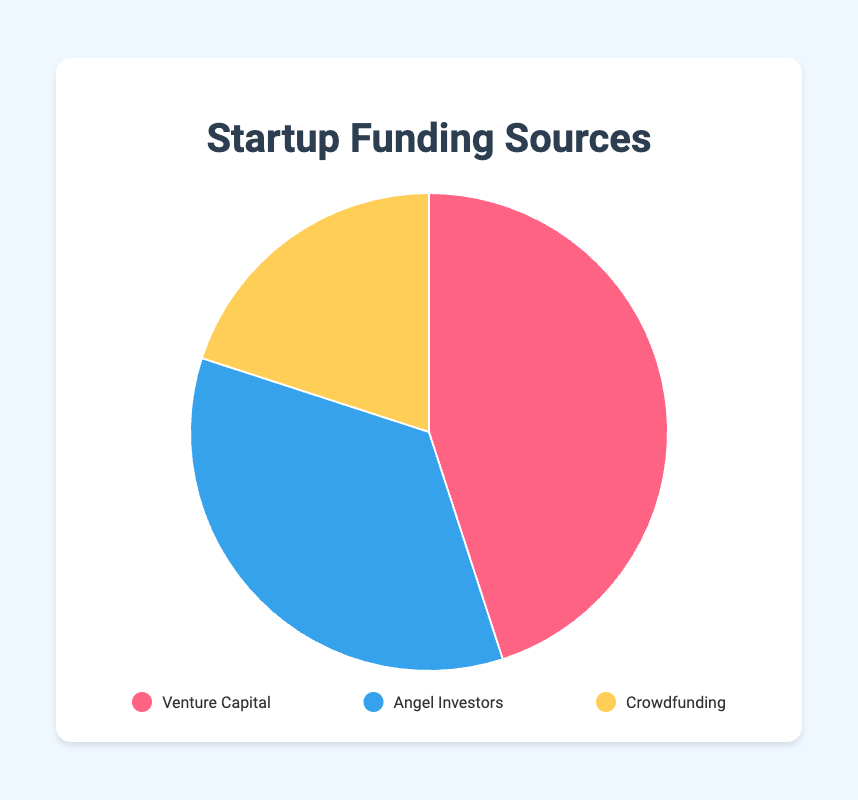what are the proportions of each funding source? Venture Capital accounts for 45%, Angel Investors for 35%, and Crowdfunding for 20%.
Answer: Venture Capital: 45%, Angel Investors: 35%, Crowdfunding: 20% Which funding source has the highest percentage? The funding source with the highest percentage in the pie chart is Venture Capital at 45%.
Answer: Venture Capital What is the total percentage of Venture Capital and Angel Investors combined? Add the percentages of Venture Capital (45%) and Angel Investors (35%). 45 + 35 = 80.
Answer: 80% How much greater, in percentage, is Venture Capital compared to Crowdfunding? Subtract Crowdfunding percentage (20%) from Venture Capital percentage (45%). 45 - 20 = 25.
Answer: 25% Are Angel Investors funding less than half of the total? Since Angel Investors account for 35%, which is less than 50%, they are indeed funding less than half of the total.
Answer: Yes Which funding source is represented by the smallest slice in the pie chart? Crowdfunding, which accounts for 20%, is the smallest slice in the pie chart.
Answer: Crowdfunding How does the percentage of Angel Investors compare to that of Crowdfunding? Angel Investors' percentage (35%) is higher than Crowdfunding's percentage (20%).
Answer: Angel Investors > Crowdfunding If you were to combine Angel Investors and Crowdfunding, would their combined percentage exceed that of Venture Capital? The combined percentage of Angel Investors (35%) and Crowdfunding (20%) is 35 + 20 = 55%, which is greater than Venture Capital's 45%.
Answer: Yes Which sources combined contribute to more than half of the total funding? Both Venture Capital (45%) and Angel Investors (35%) combined make up 80%, which is more than half. Also, combining Angel Investors (35%) and Crowdfunding (20%) gives 55%, which is more than half as well.
Answer: Venture Capital and Angel Investors; Angel Investors and Crowdfunding What color represents the Venture Capital in the pie chart? Venture Capital is represented by the red color in the pie chart.
Answer: Red 